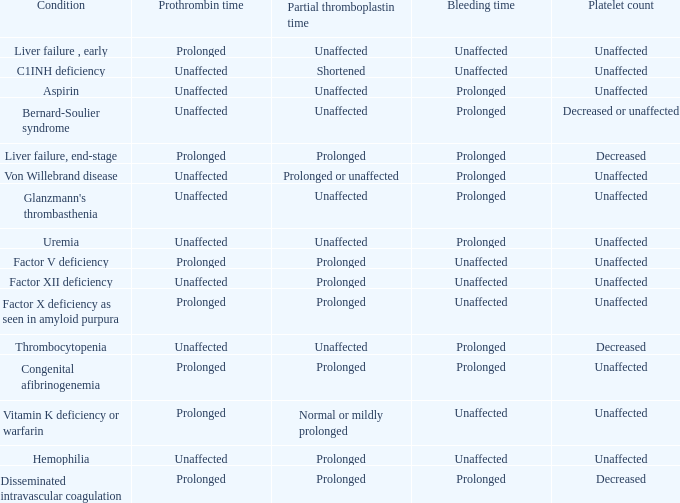What is hemophilia's bleeding time? Unaffected. 